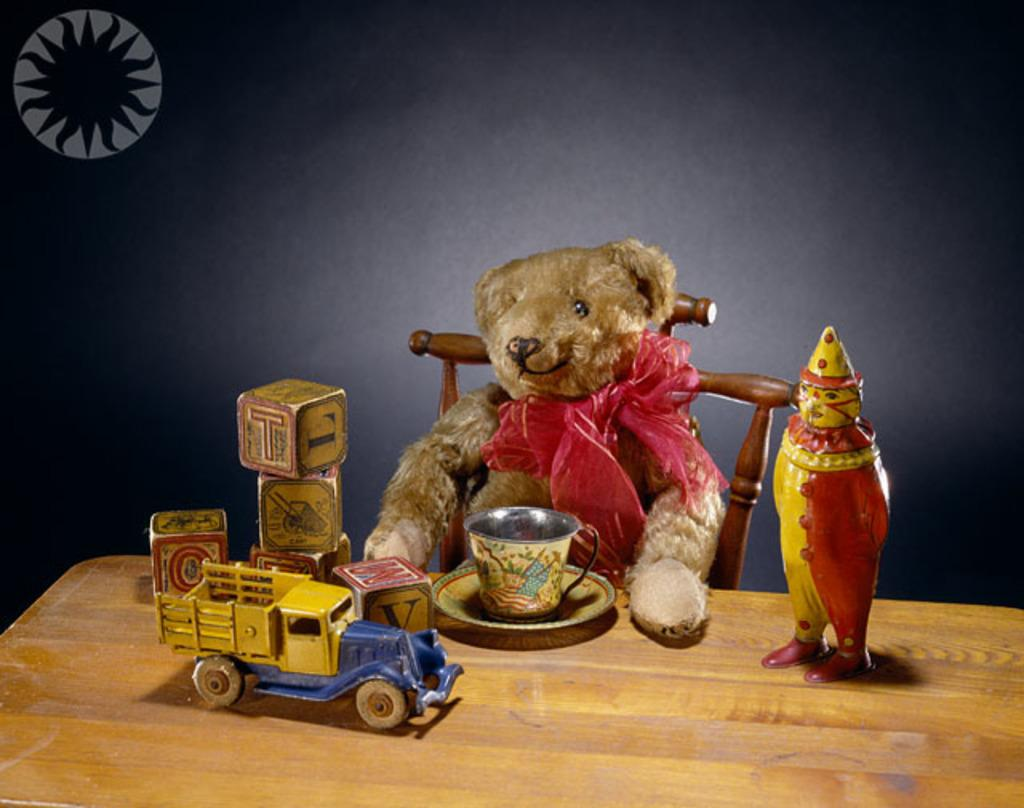What is on the chair in the image? There is a teddy bear on a chair in the image. What piece of furniture is present in the image besides the chair? There is a table in the image. What type of toys can be seen in the image? There are dolls in the image. What is on the table in the image? There is a cup and saucer on the table in the image. What color is the wall in the image? The wall in the image is black. What part of the room is visible in the image? The floor is visible in the image. What type of joke is being told by the teddy bear in the image? There is no indication that the teddy bear is telling a joke in the image. What type of border is depicted on the wall in the image? There is no border depicted on the wall in the image; it is a solid black color. 